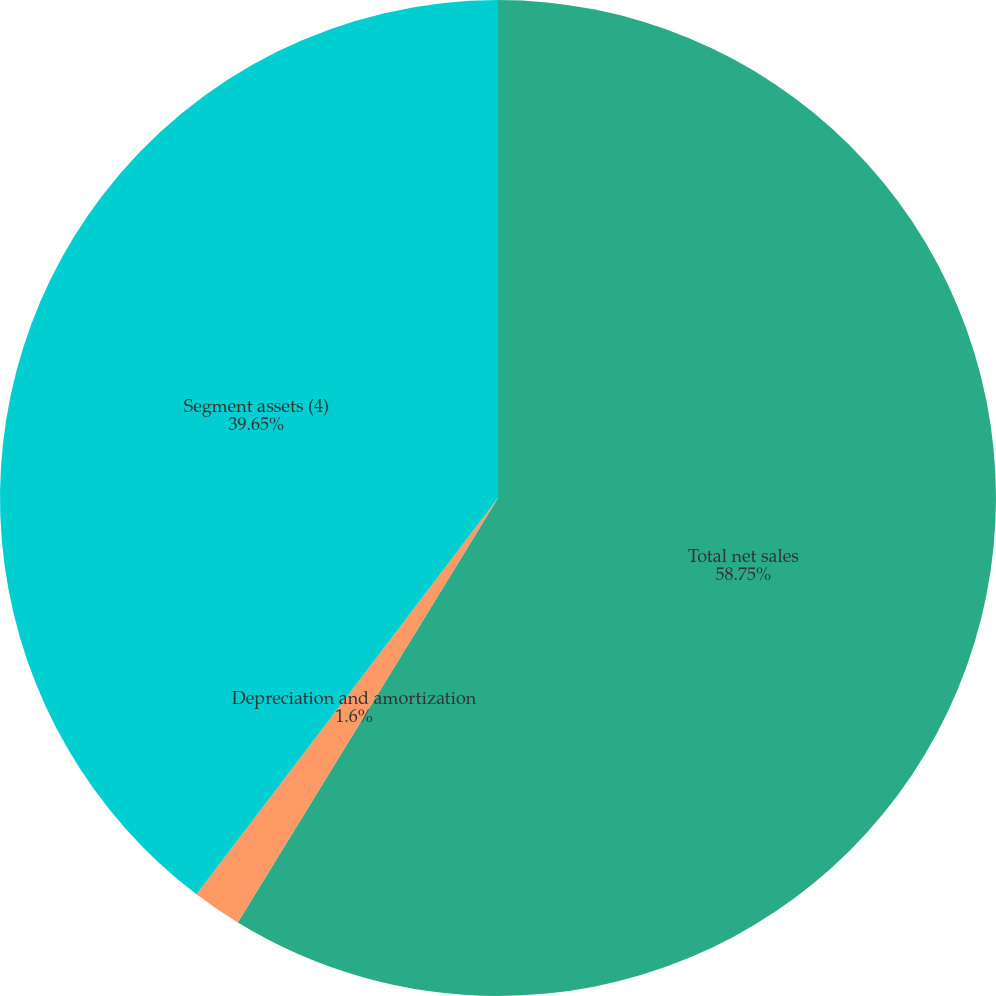<chart> <loc_0><loc_0><loc_500><loc_500><pie_chart><fcel>Total net sales<fcel>Depreciation and amortization<fcel>Segment assets (4)<nl><fcel>58.75%<fcel>1.6%<fcel>39.65%<nl></chart> 